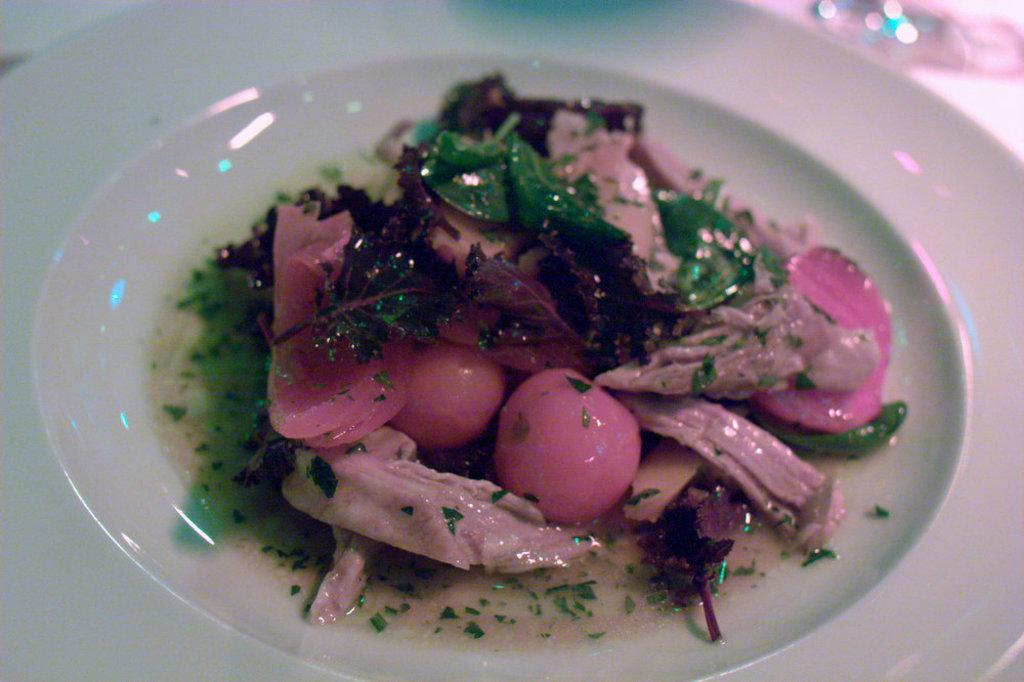What is on the plate in the image? There is food on a plate in the image. Can you describe the setting in which the plate is located? There appears to be a table in the background of the image. What type of polish is being applied to the engine in the image? There is no engine or polish present in the image. The image only shows food on a plate and a table in the background. 